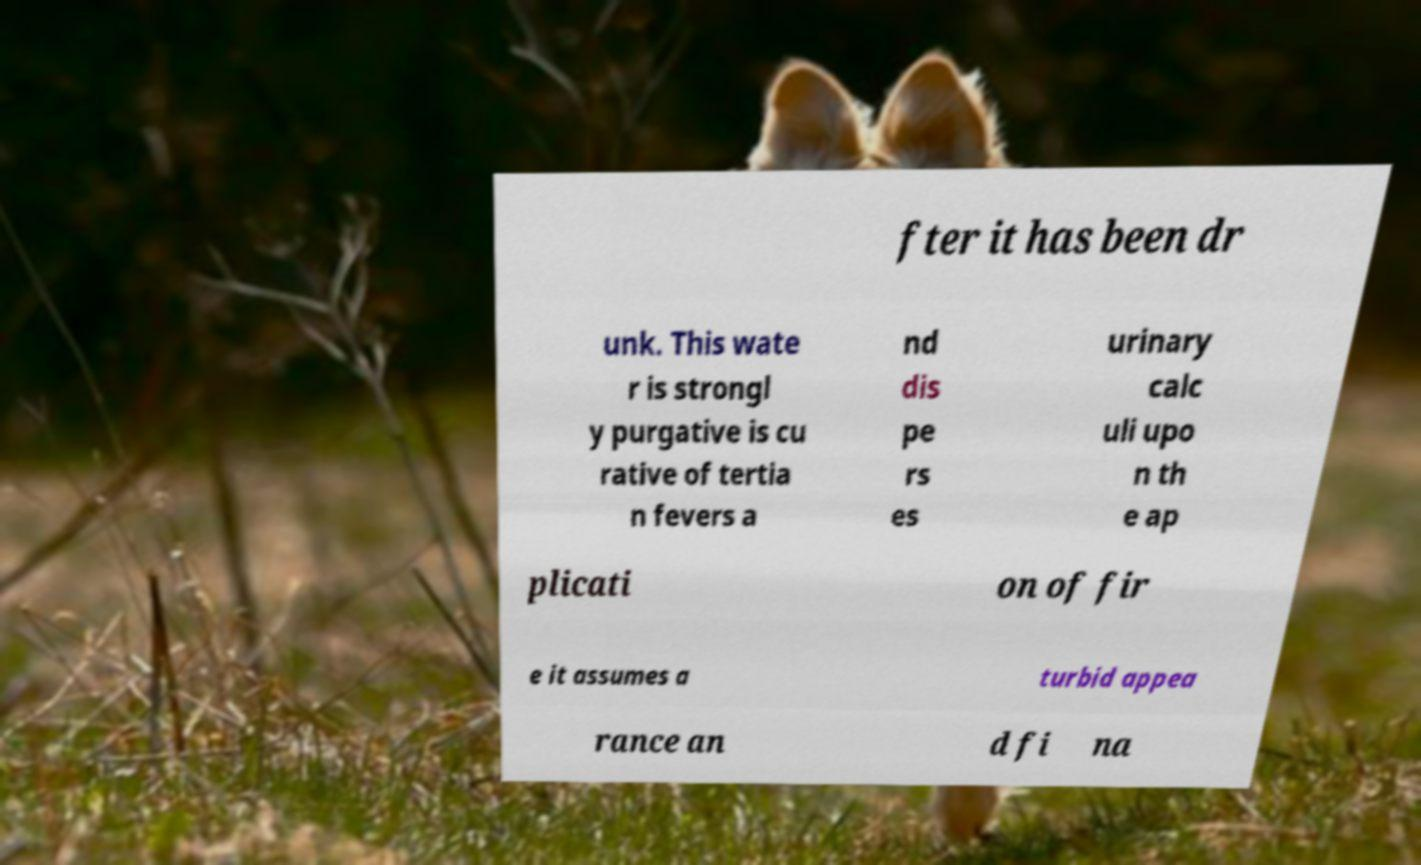Could you extract and type out the text from this image? fter it has been dr unk. This wate r is strongl y purgative is cu rative of tertia n fevers a nd dis pe rs es urinary calc uli upo n th e ap plicati on of fir e it assumes a turbid appea rance an d fi na 